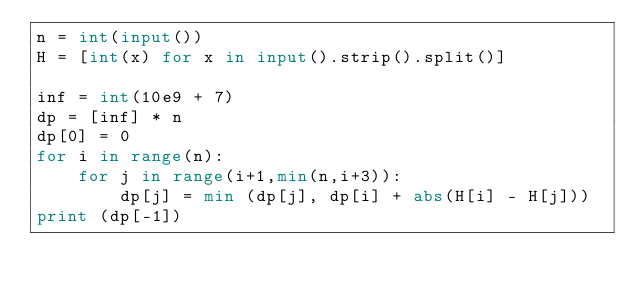Convert code to text. <code><loc_0><loc_0><loc_500><loc_500><_Python_>n = int(input())
H = [int(x) for x in input().strip().split()]

inf = int(10e9 + 7)
dp = [inf] * n
dp[0] = 0
for i in range(n):
    for j in range(i+1,min(n,i+3)):
        dp[j] = min (dp[j], dp[i] + abs(H[i] - H[j]))
print (dp[-1])</code> 